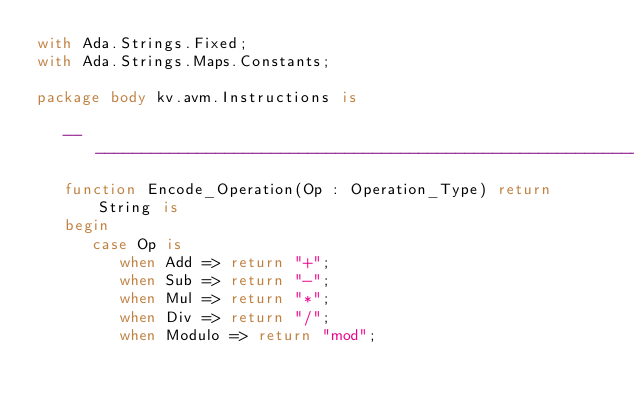<code> <loc_0><loc_0><loc_500><loc_500><_Ada_>with Ada.Strings.Fixed;
with Ada.Strings.Maps.Constants;

package body kv.avm.Instructions is

   ----------------------------------------------------------------------------
   function Encode_Operation(Op : Operation_Type) return String is
   begin
      case Op is
         when Add => return "+";
         when Sub => return "-";
         when Mul => return "*";
         when Div => return "/";
         when Modulo => return "mod";</code> 